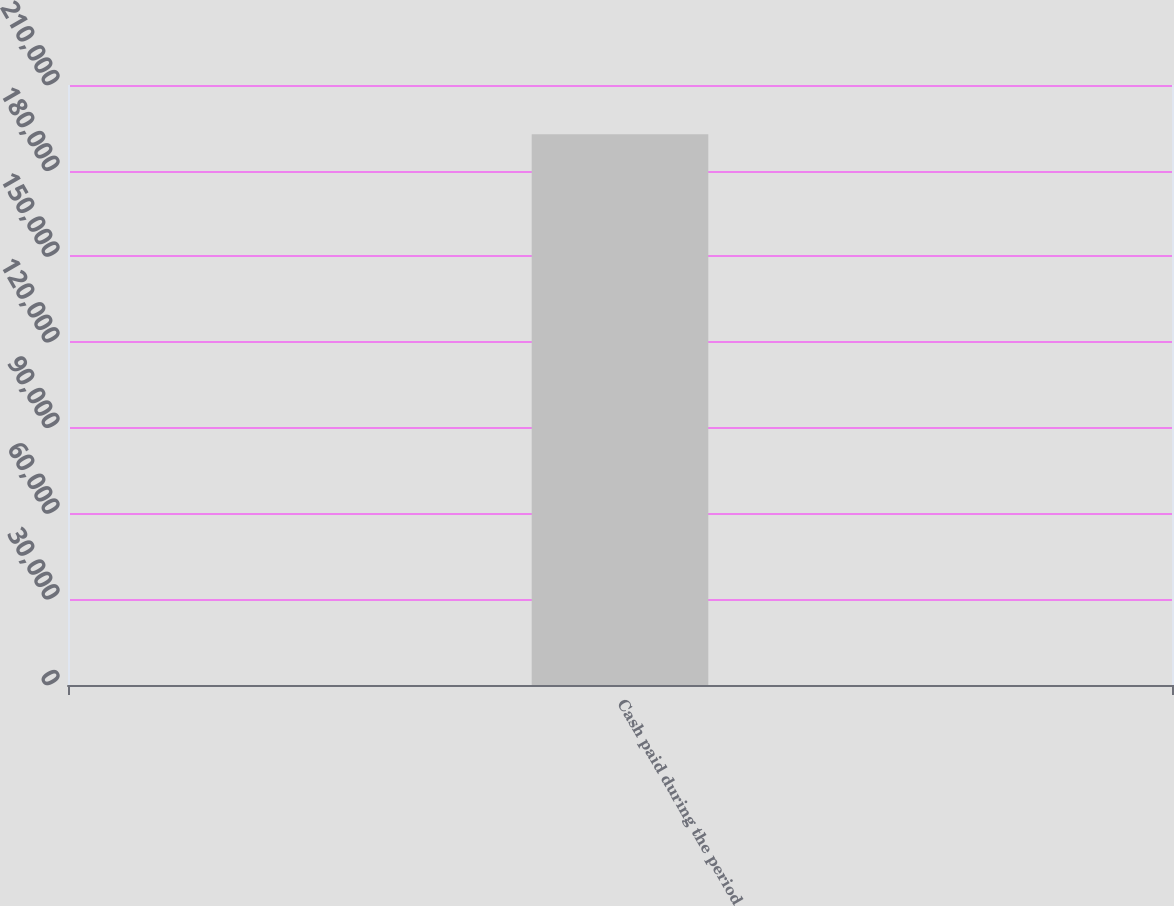<chart> <loc_0><loc_0><loc_500><loc_500><bar_chart><fcel>Cash paid during the period<nl><fcel>192794<nl></chart> 